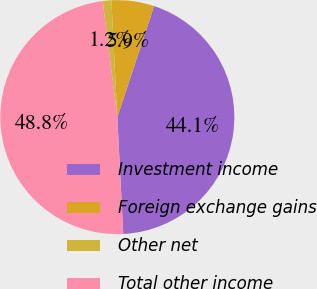Convert chart to OTSL. <chart><loc_0><loc_0><loc_500><loc_500><pie_chart><fcel>Investment income<fcel>Foreign exchange gains<fcel>Other net<fcel>Total other income<nl><fcel>44.11%<fcel>5.89%<fcel>1.19%<fcel>48.81%<nl></chart> 